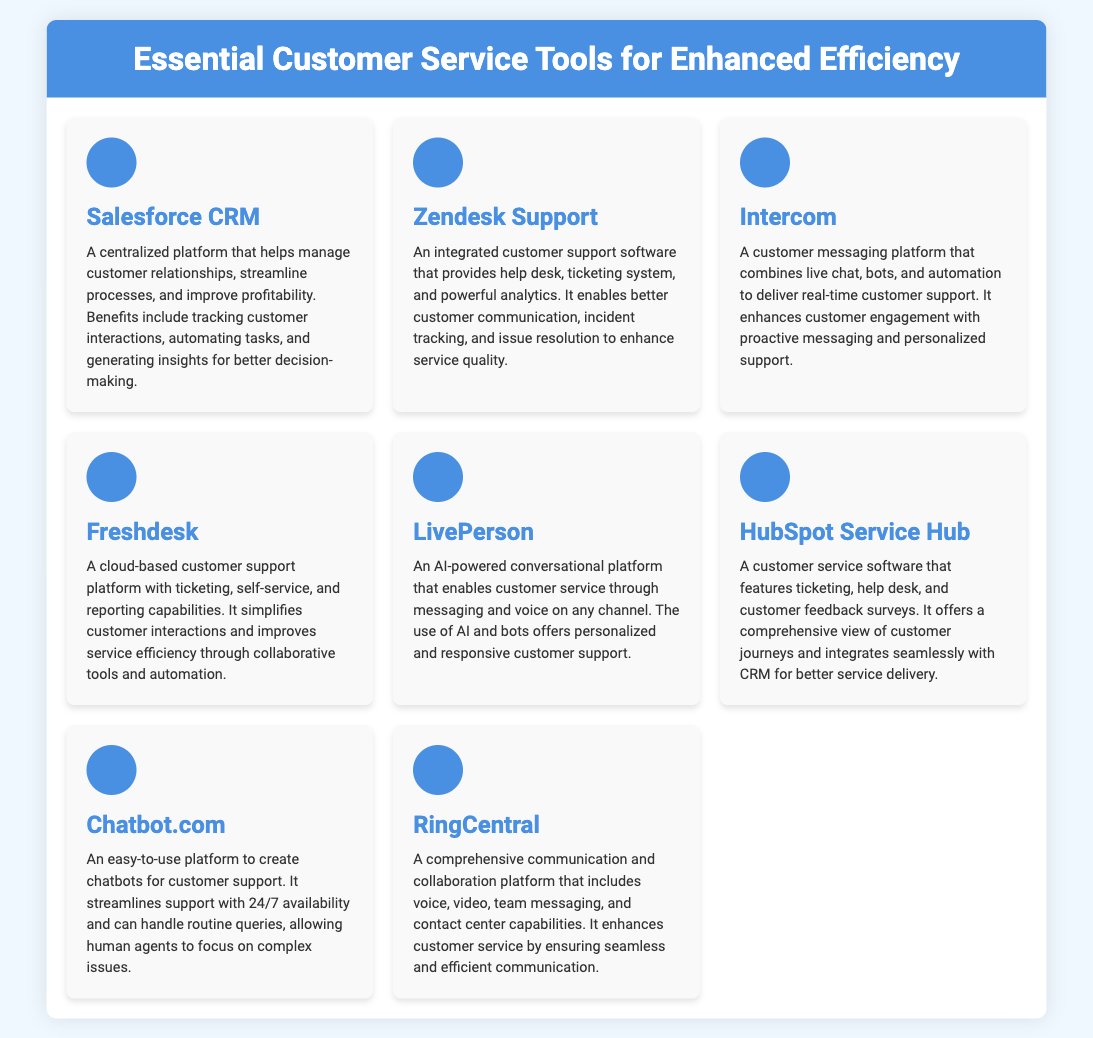What is the first tool listed? The first tool in the document is identified at the top of the list and is named Salesforce CRM.
Answer: Salesforce CRM How many customer service tools are featured? The document lists a total of eight different customer service tools in the grid.
Answer: Eight Which tool is described as AI-powered? The document specifically refers to LivePerson as the AI-powered conversational platform for customer service.
Answer: LivePerson What feature does HubSpot Service Hub offer? The document states that HubSpot Service Hub includes ticketing, help desk, and customer feedback surveys.
Answer: Ticketing What common benefit do Chatbot.com and LivePerson share? Both tools provide automated support for customers, enabling engagement without human intervention.
Answer: Automated support Which tool focuses on integrated customer support? The tool that is emphasized for integrated customer support is Zendesk Support.
Answer: Zendesk Support What is the primary function of Freshdesk? The primary function of Freshdesk as per the document is that it is a cloud-based customer support platform.
Answer: Customer support platform What type of platform is Intercom? According to the document, Intercom is described as a customer messaging platform.
Answer: Customer messaging platform 